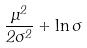Convert formula to latex. <formula><loc_0><loc_0><loc_500><loc_500>\frac { \mu ^ { 2 } } { 2 \sigma ^ { 2 } } + \ln \sigma</formula> 